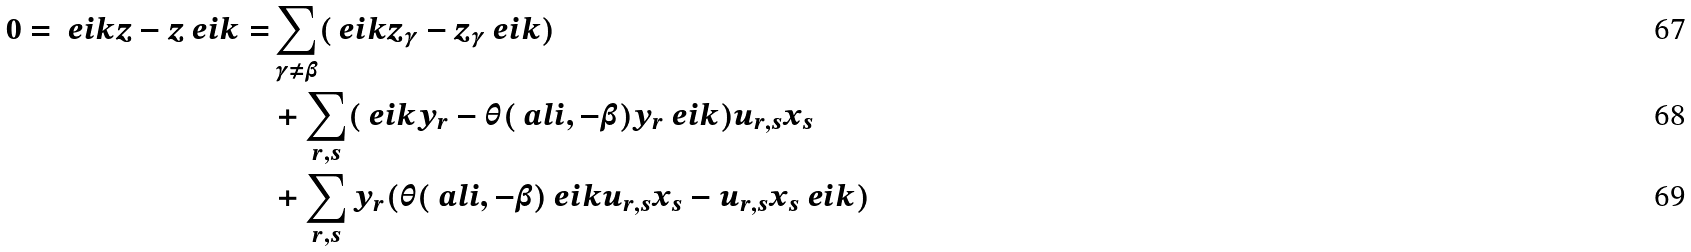Convert formula to latex. <formula><loc_0><loc_0><loc_500><loc_500>0 = \ e i k z - z \ e i k = & \sum _ { \gamma \neq \beta } ( \ e i k z _ { \gamma } - z _ { \gamma } \ e i k ) \\ & + \sum _ { r , s } ( \ e i k y _ { r } - \theta ( \ a l i , - \beta ) y _ { r } \ e i k ) u _ { r , s } x _ { s } \\ & + \sum _ { r , s } y _ { r } ( \theta ( \ a l i , - \beta ) \ e i k u _ { r , s } x _ { s } - u _ { r , s } x _ { s } \ e i k )</formula> 